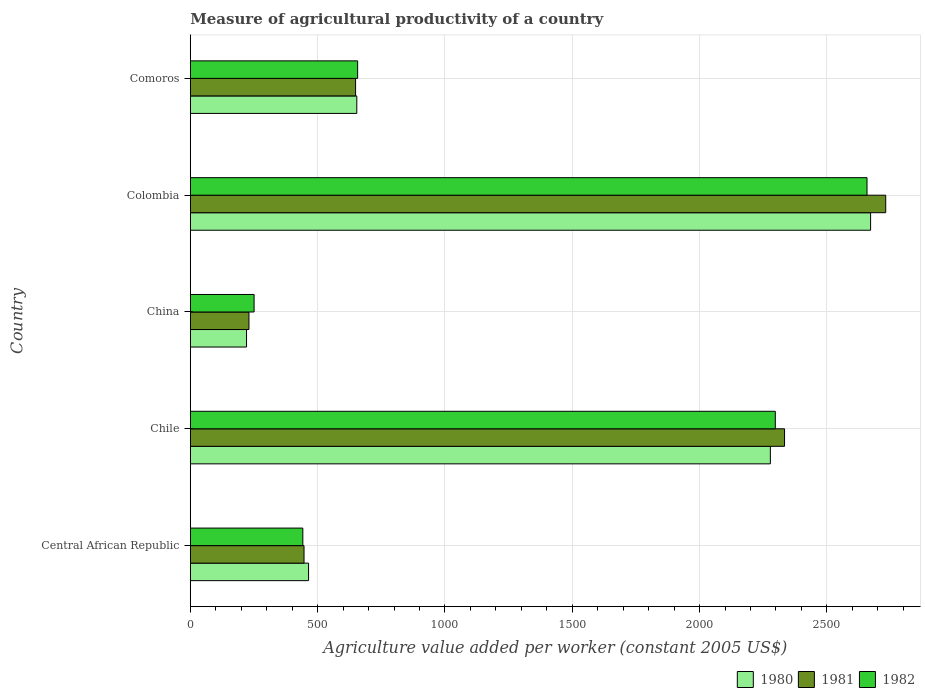How many different coloured bars are there?
Ensure brevity in your answer.  3. How many bars are there on the 4th tick from the top?
Give a very brief answer. 3. What is the label of the 5th group of bars from the top?
Ensure brevity in your answer.  Central African Republic. What is the measure of agricultural productivity in 1982 in Colombia?
Offer a terse response. 2657.56. Across all countries, what is the maximum measure of agricultural productivity in 1982?
Give a very brief answer. 2657.56. Across all countries, what is the minimum measure of agricultural productivity in 1981?
Your response must be concise. 230.38. In which country was the measure of agricultural productivity in 1980 minimum?
Give a very brief answer. China. What is the total measure of agricultural productivity in 1982 in the graph?
Keep it short and to the point. 6304.67. What is the difference between the measure of agricultural productivity in 1981 in Colombia and that in Comoros?
Offer a very short reply. 2081.9. What is the difference between the measure of agricultural productivity in 1982 in Comoros and the measure of agricultural productivity in 1981 in Chile?
Your answer should be compact. -1676.5. What is the average measure of agricultural productivity in 1982 per country?
Give a very brief answer. 1260.93. What is the difference between the measure of agricultural productivity in 1980 and measure of agricultural productivity in 1982 in Central African Republic?
Your response must be concise. 22.52. What is the ratio of the measure of agricultural productivity in 1980 in China to that in Colombia?
Your answer should be compact. 0.08. Is the measure of agricultural productivity in 1980 in Chile less than that in China?
Make the answer very short. No. Is the difference between the measure of agricultural productivity in 1980 in Colombia and Comoros greater than the difference between the measure of agricultural productivity in 1982 in Colombia and Comoros?
Keep it short and to the point. Yes. What is the difference between the highest and the second highest measure of agricultural productivity in 1981?
Keep it short and to the point. 397.34. What is the difference between the highest and the lowest measure of agricultural productivity in 1980?
Give a very brief answer. 2450.74. In how many countries, is the measure of agricultural productivity in 1982 greater than the average measure of agricultural productivity in 1982 taken over all countries?
Your answer should be very brief. 2. What does the 1st bar from the top in China represents?
Your answer should be compact. 1982. What does the 3rd bar from the bottom in Comoros represents?
Your answer should be very brief. 1982. Is it the case that in every country, the sum of the measure of agricultural productivity in 1980 and measure of agricultural productivity in 1982 is greater than the measure of agricultural productivity in 1981?
Provide a short and direct response. Yes. How many bars are there?
Your response must be concise. 15. What is the difference between two consecutive major ticks on the X-axis?
Make the answer very short. 500. Are the values on the major ticks of X-axis written in scientific E-notation?
Provide a short and direct response. No. Does the graph contain any zero values?
Provide a short and direct response. No. Does the graph contain grids?
Your answer should be compact. Yes. How are the legend labels stacked?
Your answer should be very brief. Horizontal. What is the title of the graph?
Your response must be concise. Measure of agricultural productivity of a country. What is the label or title of the X-axis?
Your answer should be compact. Agriculture value added per worker (constant 2005 US$). What is the Agriculture value added per worker (constant 2005 US$) of 1980 in Central African Republic?
Give a very brief answer. 464.44. What is the Agriculture value added per worker (constant 2005 US$) of 1981 in Central African Republic?
Keep it short and to the point. 446.67. What is the Agriculture value added per worker (constant 2005 US$) of 1982 in Central African Republic?
Give a very brief answer. 441.92. What is the Agriculture value added per worker (constant 2005 US$) in 1980 in Chile?
Provide a succinct answer. 2277.98. What is the Agriculture value added per worker (constant 2005 US$) of 1981 in Chile?
Keep it short and to the point. 2333.68. What is the Agriculture value added per worker (constant 2005 US$) of 1982 in Chile?
Provide a short and direct response. 2297.45. What is the Agriculture value added per worker (constant 2005 US$) of 1980 in China?
Offer a terse response. 220.85. What is the Agriculture value added per worker (constant 2005 US$) in 1981 in China?
Provide a succinct answer. 230.38. What is the Agriculture value added per worker (constant 2005 US$) in 1982 in China?
Your answer should be compact. 250.55. What is the Agriculture value added per worker (constant 2005 US$) in 1980 in Colombia?
Your response must be concise. 2671.6. What is the Agriculture value added per worker (constant 2005 US$) of 1981 in Colombia?
Provide a short and direct response. 2731.02. What is the Agriculture value added per worker (constant 2005 US$) in 1982 in Colombia?
Your response must be concise. 2657.56. What is the Agriculture value added per worker (constant 2005 US$) in 1980 in Comoros?
Offer a very short reply. 653.86. What is the Agriculture value added per worker (constant 2005 US$) in 1981 in Comoros?
Offer a terse response. 649.11. What is the Agriculture value added per worker (constant 2005 US$) of 1982 in Comoros?
Your answer should be very brief. 657.19. Across all countries, what is the maximum Agriculture value added per worker (constant 2005 US$) of 1980?
Your response must be concise. 2671.6. Across all countries, what is the maximum Agriculture value added per worker (constant 2005 US$) of 1981?
Ensure brevity in your answer.  2731.02. Across all countries, what is the maximum Agriculture value added per worker (constant 2005 US$) of 1982?
Offer a very short reply. 2657.56. Across all countries, what is the minimum Agriculture value added per worker (constant 2005 US$) in 1980?
Your answer should be compact. 220.85. Across all countries, what is the minimum Agriculture value added per worker (constant 2005 US$) in 1981?
Your answer should be compact. 230.38. Across all countries, what is the minimum Agriculture value added per worker (constant 2005 US$) of 1982?
Provide a short and direct response. 250.55. What is the total Agriculture value added per worker (constant 2005 US$) in 1980 in the graph?
Ensure brevity in your answer.  6288.73. What is the total Agriculture value added per worker (constant 2005 US$) of 1981 in the graph?
Offer a terse response. 6390.87. What is the total Agriculture value added per worker (constant 2005 US$) of 1982 in the graph?
Keep it short and to the point. 6304.67. What is the difference between the Agriculture value added per worker (constant 2005 US$) in 1980 in Central African Republic and that in Chile?
Make the answer very short. -1813.54. What is the difference between the Agriculture value added per worker (constant 2005 US$) in 1981 in Central African Republic and that in Chile?
Ensure brevity in your answer.  -1887.01. What is the difference between the Agriculture value added per worker (constant 2005 US$) in 1982 in Central African Republic and that in Chile?
Offer a very short reply. -1855.53. What is the difference between the Agriculture value added per worker (constant 2005 US$) in 1980 in Central African Republic and that in China?
Offer a very short reply. 243.59. What is the difference between the Agriculture value added per worker (constant 2005 US$) of 1981 in Central African Republic and that in China?
Your answer should be compact. 216.29. What is the difference between the Agriculture value added per worker (constant 2005 US$) in 1982 in Central African Republic and that in China?
Provide a short and direct response. 191.37. What is the difference between the Agriculture value added per worker (constant 2005 US$) of 1980 in Central African Republic and that in Colombia?
Provide a succinct answer. -2207.16. What is the difference between the Agriculture value added per worker (constant 2005 US$) of 1981 in Central African Republic and that in Colombia?
Keep it short and to the point. -2284.35. What is the difference between the Agriculture value added per worker (constant 2005 US$) in 1982 in Central African Republic and that in Colombia?
Provide a short and direct response. -2215.64. What is the difference between the Agriculture value added per worker (constant 2005 US$) of 1980 in Central African Republic and that in Comoros?
Offer a terse response. -189.42. What is the difference between the Agriculture value added per worker (constant 2005 US$) in 1981 in Central African Republic and that in Comoros?
Provide a succinct answer. -202.44. What is the difference between the Agriculture value added per worker (constant 2005 US$) of 1982 in Central African Republic and that in Comoros?
Offer a very short reply. -215.27. What is the difference between the Agriculture value added per worker (constant 2005 US$) of 1980 in Chile and that in China?
Your answer should be very brief. 2057.13. What is the difference between the Agriculture value added per worker (constant 2005 US$) in 1981 in Chile and that in China?
Give a very brief answer. 2103.3. What is the difference between the Agriculture value added per worker (constant 2005 US$) in 1982 in Chile and that in China?
Your answer should be very brief. 2046.9. What is the difference between the Agriculture value added per worker (constant 2005 US$) of 1980 in Chile and that in Colombia?
Make the answer very short. -393.61. What is the difference between the Agriculture value added per worker (constant 2005 US$) of 1981 in Chile and that in Colombia?
Offer a very short reply. -397.34. What is the difference between the Agriculture value added per worker (constant 2005 US$) of 1982 in Chile and that in Colombia?
Ensure brevity in your answer.  -360.11. What is the difference between the Agriculture value added per worker (constant 2005 US$) of 1980 in Chile and that in Comoros?
Your response must be concise. 1624.12. What is the difference between the Agriculture value added per worker (constant 2005 US$) in 1981 in Chile and that in Comoros?
Provide a succinct answer. 1684.57. What is the difference between the Agriculture value added per worker (constant 2005 US$) of 1982 in Chile and that in Comoros?
Give a very brief answer. 1640.27. What is the difference between the Agriculture value added per worker (constant 2005 US$) in 1980 in China and that in Colombia?
Keep it short and to the point. -2450.74. What is the difference between the Agriculture value added per worker (constant 2005 US$) in 1981 in China and that in Colombia?
Make the answer very short. -2500.64. What is the difference between the Agriculture value added per worker (constant 2005 US$) of 1982 in China and that in Colombia?
Offer a terse response. -2407.01. What is the difference between the Agriculture value added per worker (constant 2005 US$) in 1980 in China and that in Comoros?
Offer a very short reply. -433.01. What is the difference between the Agriculture value added per worker (constant 2005 US$) in 1981 in China and that in Comoros?
Ensure brevity in your answer.  -418.73. What is the difference between the Agriculture value added per worker (constant 2005 US$) of 1982 in China and that in Comoros?
Provide a short and direct response. -406.63. What is the difference between the Agriculture value added per worker (constant 2005 US$) of 1980 in Colombia and that in Comoros?
Ensure brevity in your answer.  2017.73. What is the difference between the Agriculture value added per worker (constant 2005 US$) in 1981 in Colombia and that in Comoros?
Your response must be concise. 2081.9. What is the difference between the Agriculture value added per worker (constant 2005 US$) in 1982 in Colombia and that in Comoros?
Your response must be concise. 2000.38. What is the difference between the Agriculture value added per worker (constant 2005 US$) in 1980 in Central African Republic and the Agriculture value added per worker (constant 2005 US$) in 1981 in Chile?
Keep it short and to the point. -1869.24. What is the difference between the Agriculture value added per worker (constant 2005 US$) in 1980 in Central African Republic and the Agriculture value added per worker (constant 2005 US$) in 1982 in Chile?
Give a very brief answer. -1833.01. What is the difference between the Agriculture value added per worker (constant 2005 US$) in 1981 in Central African Republic and the Agriculture value added per worker (constant 2005 US$) in 1982 in Chile?
Provide a succinct answer. -1850.78. What is the difference between the Agriculture value added per worker (constant 2005 US$) of 1980 in Central African Republic and the Agriculture value added per worker (constant 2005 US$) of 1981 in China?
Give a very brief answer. 234.06. What is the difference between the Agriculture value added per worker (constant 2005 US$) in 1980 in Central African Republic and the Agriculture value added per worker (constant 2005 US$) in 1982 in China?
Ensure brevity in your answer.  213.89. What is the difference between the Agriculture value added per worker (constant 2005 US$) in 1981 in Central African Republic and the Agriculture value added per worker (constant 2005 US$) in 1982 in China?
Your answer should be very brief. 196.12. What is the difference between the Agriculture value added per worker (constant 2005 US$) of 1980 in Central African Republic and the Agriculture value added per worker (constant 2005 US$) of 1981 in Colombia?
Offer a very short reply. -2266.58. What is the difference between the Agriculture value added per worker (constant 2005 US$) of 1980 in Central African Republic and the Agriculture value added per worker (constant 2005 US$) of 1982 in Colombia?
Your answer should be compact. -2193.12. What is the difference between the Agriculture value added per worker (constant 2005 US$) of 1981 in Central African Republic and the Agriculture value added per worker (constant 2005 US$) of 1982 in Colombia?
Provide a succinct answer. -2210.89. What is the difference between the Agriculture value added per worker (constant 2005 US$) in 1980 in Central African Republic and the Agriculture value added per worker (constant 2005 US$) in 1981 in Comoros?
Your answer should be compact. -184.68. What is the difference between the Agriculture value added per worker (constant 2005 US$) of 1980 in Central African Republic and the Agriculture value added per worker (constant 2005 US$) of 1982 in Comoros?
Offer a very short reply. -192.75. What is the difference between the Agriculture value added per worker (constant 2005 US$) in 1981 in Central African Republic and the Agriculture value added per worker (constant 2005 US$) in 1982 in Comoros?
Offer a terse response. -210.51. What is the difference between the Agriculture value added per worker (constant 2005 US$) in 1980 in Chile and the Agriculture value added per worker (constant 2005 US$) in 1981 in China?
Offer a very short reply. 2047.6. What is the difference between the Agriculture value added per worker (constant 2005 US$) in 1980 in Chile and the Agriculture value added per worker (constant 2005 US$) in 1982 in China?
Make the answer very short. 2027.43. What is the difference between the Agriculture value added per worker (constant 2005 US$) of 1981 in Chile and the Agriculture value added per worker (constant 2005 US$) of 1982 in China?
Offer a terse response. 2083.13. What is the difference between the Agriculture value added per worker (constant 2005 US$) in 1980 in Chile and the Agriculture value added per worker (constant 2005 US$) in 1981 in Colombia?
Provide a succinct answer. -453.04. What is the difference between the Agriculture value added per worker (constant 2005 US$) in 1980 in Chile and the Agriculture value added per worker (constant 2005 US$) in 1982 in Colombia?
Offer a terse response. -379.58. What is the difference between the Agriculture value added per worker (constant 2005 US$) in 1981 in Chile and the Agriculture value added per worker (constant 2005 US$) in 1982 in Colombia?
Provide a short and direct response. -323.88. What is the difference between the Agriculture value added per worker (constant 2005 US$) of 1980 in Chile and the Agriculture value added per worker (constant 2005 US$) of 1981 in Comoros?
Provide a succinct answer. 1628.87. What is the difference between the Agriculture value added per worker (constant 2005 US$) of 1980 in Chile and the Agriculture value added per worker (constant 2005 US$) of 1982 in Comoros?
Make the answer very short. 1620.8. What is the difference between the Agriculture value added per worker (constant 2005 US$) in 1981 in Chile and the Agriculture value added per worker (constant 2005 US$) in 1982 in Comoros?
Your answer should be very brief. 1676.5. What is the difference between the Agriculture value added per worker (constant 2005 US$) in 1980 in China and the Agriculture value added per worker (constant 2005 US$) in 1981 in Colombia?
Your answer should be compact. -2510.17. What is the difference between the Agriculture value added per worker (constant 2005 US$) of 1980 in China and the Agriculture value added per worker (constant 2005 US$) of 1982 in Colombia?
Your answer should be very brief. -2436.71. What is the difference between the Agriculture value added per worker (constant 2005 US$) of 1981 in China and the Agriculture value added per worker (constant 2005 US$) of 1982 in Colombia?
Provide a short and direct response. -2427.18. What is the difference between the Agriculture value added per worker (constant 2005 US$) of 1980 in China and the Agriculture value added per worker (constant 2005 US$) of 1981 in Comoros?
Give a very brief answer. -428.26. What is the difference between the Agriculture value added per worker (constant 2005 US$) in 1980 in China and the Agriculture value added per worker (constant 2005 US$) in 1982 in Comoros?
Keep it short and to the point. -436.33. What is the difference between the Agriculture value added per worker (constant 2005 US$) in 1981 in China and the Agriculture value added per worker (constant 2005 US$) in 1982 in Comoros?
Keep it short and to the point. -426.8. What is the difference between the Agriculture value added per worker (constant 2005 US$) in 1980 in Colombia and the Agriculture value added per worker (constant 2005 US$) in 1981 in Comoros?
Your answer should be very brief. 2022.48. What is the difference between the Agriculture value added per worker (constant 2005 US$) in 1980 in Colombia and the Agriculture value added per worker (constant 2005 US$) in 1982 in Comoros?
Your answer should be compact. 2014.41. What is the difference between the Agriculture value added per worker (constant 2005 US$) of 1981 in Colombia and the Agriculture value added per worker (constant 2005 US$) of 1982 in Comoros?
Ensure brevity in your answer.  2073.83. What is the average Agriculture value added per worker (constant 2005 US$) in 1980 per country?
Ensure brevity in your answer.  1257.75. What is the average Agriculture value added per worker (constant 2005 US$) in 1981 per country?
Offer a very short reply. 1278.17. What is the average Agriculture value added per worker (constant 2005 US$) of 1982 per country?
Keep it short and to the point. 1260.93. What is the difference between the Agriculture value added per worker (constant 2005 US$) of 1980 and Agriculture value added per worker (constant 2005 US$) of 1981 in Central African Republic?
Offer a very short reply. 17.77. What is the difference between the Agriculture value added per worker (constant 2005 US$) of 1980 and Agriculture value added per worker (constant 2005 US$) of 1982 in Central African Republic?
Your answer should be very brief. 22.52. What is the difference between the Agriculture value added per worker (constant 2005 US$) of 1981 and Agriculture value added per worker (constant 2005 US$) of 1982 in Central African Republic?
Your response must be concise. 4.75. What is the difference between the Agriculture value added per worker (constant 2005 US$) of 1980 and Agriculture value added per worker (constant 2005 US$) of 1981 in Chile?
Your response must be concise. -55.7. What is the difference between the Agriculture value added per worker (constant 2005 US$) in 1980 and Agriculture value added per worker (constant 2005 US$) in 1982 in Chile?
Your answer should be very brief. -19.47. What is the difference between the Agriculture value added per worker (constant 2005 US$) in 1981 and Agriculture value added per worker (constant 2005 US$) in 1982 in Chile?
Provide a short and direct response. 36.23. What is the difference between the Agriculture value added per worker (constant 2005 US$) of 1980 and Agriculture value added per worker (constant 2005 US$) of 1981 in China?
Your answer should be very brief. -9.53. What is the difference between the Agriculture value added per worker (constant 2005 US$) of 1980 and Agriculture value added per worker (constant 2005 US$) of 1982 in China?
Your answer should be compact. -29.7. What is the difference between the Agriculture value added per worker (constant 2005 US$) of 1981 and Agriculture value added per worker (constant 2005 US$) of 1982 in China?
Your response must be concise. -20.17. What is the difference between the Agriculture value added per worker (constant 2005 US$) of 1980 and Agriculture value added per worker (constant 2005 US$) of 1981 in Colombia?
Provide a short and direct response. -59.42. What is the difference between the Agriculture value added per worker (constant 2005 US$) in 1980 and Agriculture value added per worker (constant 2005 US$) in 1982 in Colombia?
Make the answer very short. 14.03. What is the difference between the Agriculture value added per worker (constant 2005 US$) in 1981 and Agriculture value added per worker (constant 2005 US$) in 1982 in Colombia?
Your response must be concise. 73.46. What is the difference between the Agriculture value added per worker (constant 2005 US$) in 1980 and Agriculture value added per worker (constant 2005 US$) in 1981 in Comoros?
Offer a terse response. 4.75. What is the difference between the Agriculture value added per worker (constant 2005 US$) of 1980 and Agriculture value added per worker (constant 2005 US$) of 1982 in Comoros?
Give a very brief answer. -3.33. What is the difference between the Agriculture value added per worker (constant 2005 US$) in 1981 and Agriculture value added per worker (constant 2005 US$) in 1982 in Comoros?
Ensure brevity in your answer.  -8.07. What is the ratio of the Agriculture value added per worker (constant 2005 US$) of 1980 in Central African Republic to that in Chile?
Your response must be concise. 0.2. What is the ratio of the Agriculture value added per worker (constant 2005 US$) of 1981 in Central African Republic to that in Chile?
Keep it short and to the point. 0.19. What is the ratio of the Agriculture value added per worker (constant 2005 US$) in 1982 in Central African Republic to that in Chile?
Provide a succinct answer. 0.19. What is the ratio of the Agriculture value added per worker (constant 2005 US$) in 1980 in Central African Republic to that in China?
Offer a very short reply. 2.1. What is the ratio of the Agriculture value added per worker (constant 2005 US$) in 1981 in Central African Republic to that in China?
Your answer should be very brief. 1.94. What is the ratio of the Agriculture value added per worker (constant 2005 US$) in 1982 in Central African Republic to that in China?
Your answer should be very brief. 1.76. What is the ratio of the Agriculture value added per worker (constant 2005 US$) in 1980 in Central African Republic to that in Colombia?
Offer a very short reply. 0.17. What is the ratio of the Agriculture value added per worker (constant 2005 US$) of 1981 in Central African Republic to that in Colombia?
Provide a short and direct response. 0.16. What is the ratio of the Agriculture value added per worker (constant 2005 US$) in 1982 in Central African Republic to that in Colombia?
Provide a short and direct response. 0.17. What is the ratio of the Agriculture value added per worker (constant 2005 US$) in 1980 in Central African Republic to that in Comoros?
Keep it short and to the point. 0.71. What is the ratio of the Agriculture value added per worker (constant 2005 US$) of 1981 in Central African Republic to that in Comoros?
Offer a terse response. 0.69. What is the ratio of the Agriculture value added per worker (constant 2005 US$) in 1982 in Central African Republic to that in Comoros?
Offer a very short reply. 0.67. What is the ratio of the Agriculture value added per worker (constant 2005 US$) of 1980 in Chile to that in China?
Your answer should be very brief. 10.31. What is the ratio of the Agriculture value added per worker (constant 2005 US$) in 1981 in Chile to that in China?
Make the answer very short. 10.13. What is the ratio of the Agriculture value added per worker (constant 2005 US$) in 1982 in Chile to that in China?
Your response must be concise. 9.17. What is the ratio of the Agriculture value added per worker (constant 2005 US$) of 1980 in Chile to that in Colombia?
Your answer should be compact. 0.85. What is the ratio of the Agriculture value added per worker (constant 2005 US$) of 1981 in Chile to that in Colombia?
Your answer should be compact. 0.85. What is the ratio of the Agriculture value added per worker (constant 2005 US$) in 1982 in Chile to that in Colombia?
Your answer should be compact. 0.86. What is the ratio of the Agriculture value added per worker (constant 2005 US$) in 1980 in Chile to that in Comoros?
Make the answer very short. 3.48. What is the ratio of the Agriculture value added per worker (constant 2005 US$) of 1981 in Chile to that in Comoros?
Your answer should be very brief. 3.6. What is the ratio of the Agriculture value added per worker (constant 2005 US$) in 1982 in Chile to that in Comoros?
Keep it short and to the point. 3.5. What is the ratio of the Agriculture value added per worker (constant 2005 US$) in 1980 in China to that in Colombia?
Offer a very short reply. 0.08. What is the ratio of the Agriculture value added per worker (constant 2005 US$) in 1981 in China to that in Colombia?
Provide a succinct answer. 0.08. What is the ratio of the Agriculture value added per worker (constant 2005 US$) in 1982 in China to that in Colombia?
Provide a succinct answer. 0.09. What is the ratio of the Agriculture value added per worker (constant 2005 US$) of 1980 in China to that in Comoros?
Ensure brevity in your answer.  0.34. What is the ratio of the Agriculture value added per worker (constant 2005 US$) in 1981 in China to that in Comoros?
Offer a terse response. 0.35. What is the ratio of the Agriculture value added per worker (constant 2005 US$) in 1982 in China to that in Comoros?
Ensure brevity in your answer.  0.38. What is the ratio of the Agriculture value added per worker (constant 2005 US$) of 1980 in Colombia to that in Comoros?
Give a very brief answer. 4.09. What is the ratio of the Agriculture value added per worker (constant 2005 US$) of 1981 in Colombia to that in Comoros?
Your answer should be very brief. 4.21. What is the ratio of the Agriculture value added per worker (constant 2005 US$) of 1982 in Colombia to that in Comoros?
Your answer should be very brief. 4.04. What is the difference between the highest and the second highest Agriculture value added per worker (constant 2005 US$) in 1980?
Your answer should be very brief. 393.61. What is the difference between the highest and the second highest Agriculture value added per worker (constant 2005 US$) of 1981?
Your answer should be compact. 397.34. What is the difference between the highest and the second highest Agriculture value added per worker (constant 2005 US$) of 1982?
Keep it short and to the point. 360.11. What is the difference between the highest and the lowest Agriculture value added per worker (constant 2005 US$) of 1980?
Provide a short and direct response. 2450.74. What is the difference between the highest and the lowest Agriculture value added per worker (constant 2005 US$) of 1981?
Your answer should be very brief. 2500.64. What is the difference between the highest and the lowest Agriculture value added per worker (constant 2005 US$) in 1982?
Give a very brief answer. 2407.01. 